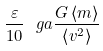Convert formula to latex. <formula><loc_0><loc_0><loc_500><loc_500>\frac { \varepsilon } { 1 0 } \ g a \frac { G \left \langle m \right \rangle } { \left \langle v ^ { 2 } \right \rangle }</formula> 